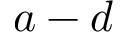Convert formula to latex. <formula><loc_0><loc_0><loc_500><loc_500>a - d</formula> 